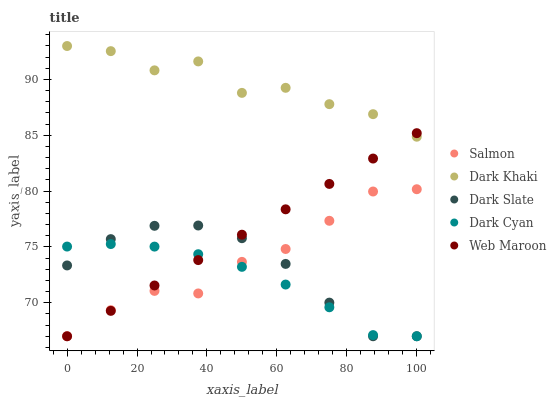Does Dark Cyan have the minimum area under the curve?
Answer yes or no. Yes. Does Dark Khaki have the maximum area under the curve?
Answer yes or no. Yes. Does Dark Slate have the minimum area under the curve?
Answer yes or no. No. Does Dark Slate have the maximum area under the curve?
Answer yes or no. No. Is Web Maroon the smoothest?
Answer yes or no. Yes. Is Dark Khaki the roughest?
Answer yes or no. Yes. Is Dark Slate the smoothest?
Answer yes or no. No. Is Dark Slate the roughest?
Answer yes or no. No. Does Dark Slate have the lowest value?
Answer yes or no. Yes. Does Dark Khaki have the highest value?
Answer yes or no. Yes. Does Dark Slate have the highest value?
Answer yes or no. No. Is Dark Slate less than Dark Khaki?
Answer yes or no. Yes. Is Dark Khaki greater than Salmon?
Answer yes or no. Yes. Does Web Maroon intersect Dark Khaki?
Answer yes or no. Yes. Is Web Maroon less than Dark Khaki?
Answer yes or no. No. Is Web Maroon greater than Dark Khaki?
Answer yes or no. No. Does Dark Slate intersect Dark Khaki?
Answer yes or no. No. 